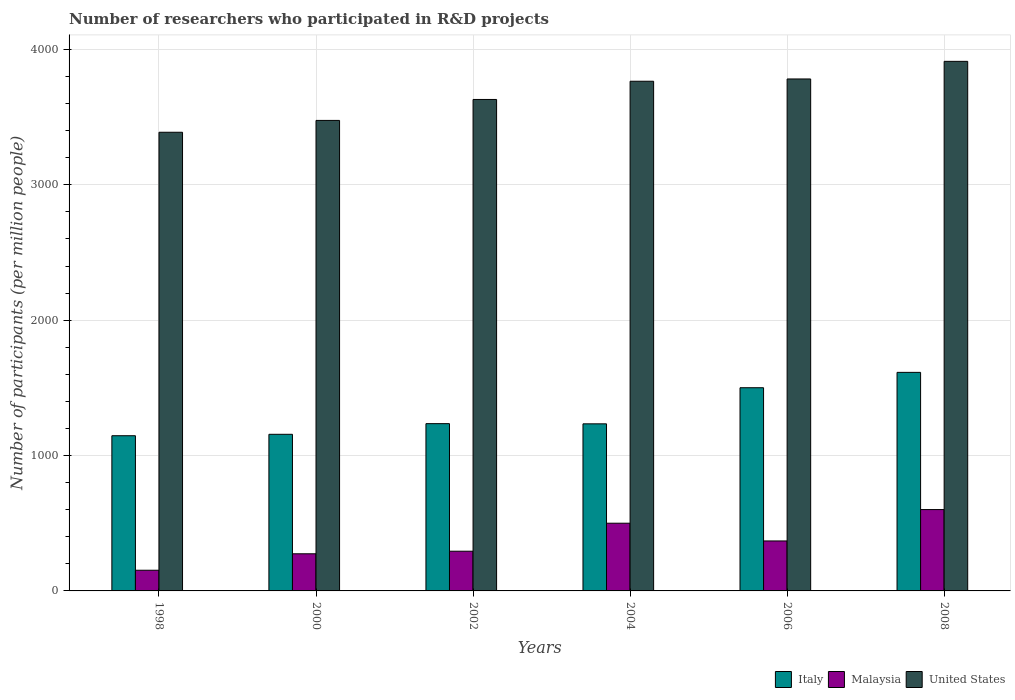Are the number of bars per tick equal to the number of legend labels?
Provide a succinct answer. Yes. What is the number of researchers who participated in R&D projects in Italy in 2002?
Ensure brevity in your answer.  1235.65. Across all years, what is the maximum number of researchers who participated in R&D projects in Italy?
Provide a short and direct response. 1614.42. Across all years, what is the minimum number of researchers who participated in R&D projects in Italy?
Give a very brief answer. 1146.34. What is the total number of researchers who participated in R&D projects in United States in the graph?
Make the answer very short. 2.20e+04. What is the difference between the number of researchers who participated in R&D projects in Malaysia in 2004 and that in 2006?
Your answer should be very brief. 131.01. What is the difference between the number of researchers who participated in R&D projects in Malaysia in 2000 and the number of researchers who participated in R&D projects in Italy in 2008?
Ensure brevity in your answer.  -1340.18. What is the average number of researchers who participated in R&D projects in Italy per year?
Keep it short and to the point. 1314.72. In the year 2000, what is the difference between the number of researchers who participated in R&D projects in Malaysia and number of researchers who participated in R&D projects in Italy?
Provide a short and direct response. -882.6. What is the ratio of the number of researchers who participated in R&D projects in United States in 2004 to that in 2008?
Keep it short and to the point. 0.96. What is the difference between the highest and the second highest number of researchers who participated in R&D projects in Malaysia?
Provide a succinct answer. 100.82. What is the difference between the highest and the lowest number of researchers who participated in R&D projects in United States?
Give a very brief answer. 523.75. Is the sum of the number of researchers who participated in R&D projects in United States in 1998 and 2000 greater than the maximum number of researchers who participated in R&D projects in Italy across all years?
Keep it short and to the point. Yes. What does the 1st bar from the left in 2008 represents?
Give a very brief answer. Italy. What does the 3rd bar from the right in 2008 represents?
Ensure brevity in your answer.  Italy. Is it the case that in every year, the sum of the number of researchers who participated in R&D projects in Malaysia and number of researchers who participated in R&D projects in United States is greater than the number of researchers who participated in R&D projects in Italy?
Provide a short and direct response. Yes. How many bars are there?
Keep it short and to the point. 18. Are all the bars in the graph horizontal?
Your answer should be compact. No. What is the difference between two consecutive major ticks on the Y-axis?
Make the answer very short. 1000. Does the graph contain any zero values?
Provide a short and direct response. No. Where does the legend appear in the graph?
Ensure brevity in your answer.  Bottom right. What is the title of the graph?
Provide a succinct answer. Number of researchers who participated in R&D projects. What is the label or title of the Y-axis?
Provide a succinct answer. Number of participants (per million people). What is the Number of participants (per million people) in Italy in 1998?
Provide a short and direct response. 1146.34. What is the Number of participants (per million people) of Malaysia in 1998?
Provide a succinct answer. 152.79. What is the Number of participants (per million people) in United States in 1998?
Give a very brief answer. 3388.01. What is the Number of participants (per million people) in Italy in 2000?
Ensure brevity in your answer.  1156.84. What is the Number of participants (per million people) in Malaysia in 2000?
Provide a succinct answer. 274.24. What is the Number of participants (per million people) of United States in 2000?
Your answer should be compact. 3475.52. What is the Number of participants (per million people) of Italy in 2002?
Your answer should be compact. 1235.65. What is the Number of participants (per million people) of Malaysia in 2002?
Your response must be concise. 293.3. What is the Number of participants (per million people) in United States in 2002?
Offer a very short reply. 3630.32. What is the Number of participants (per million people) in Italy in 2004?
Provide a succinct answer. 1234.18. What is the Number of participants (per million people) in Malaysia in 2004?
Give a very brief answer. 500.14. What is the Number of participants (per million people) in United States in 2004?
Ensure brevity in your answer.  3764.84. What is the Number of participants (per million people) of Italy in 2006?
Provide a succinct answer. 1500.88. What is the Number of participants (per million people) in Malaysia in 2006?
Your answer should be very brief. 369.12. What is the Number of participants (per million people) of United States in 2006?
Your answer should be compact. 3781.64. What is the Number of participants (per million people) of Italy in 2008?
Give a very brief answer. 1614.42. What is the Number of participants (per million people) in Malaysia in 2008?
Ensure brevity in your answer.  600.96. What is the Number of participants (per million people) in United States in 2008?
Your answer should be very brief. 3911.75. Across all years, what is the maximum Number of participants (per million people) of Italy?
Your response must be concise. 1614.42. Across all years, what is the maximum Number of participants (per million people) of Malaysia?
Keep it short and to the point. 600.96. Across all years, what is the maximum Number of participants (per million people) of United States?
Provide a succinct answer. 3911.75. Across all years, what is the minimum Number of participants (per million people) of Italy?
Your response must be concise. 1146.34. Across all years, what is the minimum Number of participants (per million people) in Malaysia?
Offer a terse response. 152.79. Across all years, what is the minimum Number of participants (per million people) of United States?
Your response must be concise. 3388.01. What is the total Number of participants (per million people) of Italy in the graph?
Provide a succinct answer. 7888.31. What is the total Number of participants (per million people) in Malaysia in the graph?
Your answer should be compact. 2190.55. What is the total Number of participants (per million people) in United States in the graph?
Your answer should be compact. 2.20e+04. What is the difference between the Number of participants (per million people) in Italy in 1998 and that in 2000?
Provide a short and direct response. -10.5. What is the difference between the Number of participants (per million people) in Malaysia in 1998 and that in 2000?
Your response must be concise. -121.46. What is the difference between the Number of participants (per million people) in United States in 1998 and that in 2000?
Provide a short and direct response. -87.51. What is the difference between the Number of participants (per million people) in Italy in 1998 and that in 2002?
Your response must be concise. -89.3. What is the difference between the Number of participants (per million people) of Malaysia in 1998 and that in 2002?
Provide a short and direct response. -140.51. What is the difference between the Number of participants (per million people) in United States in 1998 and that in 2002?
Provide a short and direct response. -242.31. What is the difference between the Number of participants (per million people) of Italy in 1998 and that in 2004?
Your answer should be very brief. -87.83. What is the difference between the Number of participants (per million people) of Malaysia in 1998 and that in 2004?
Keep it short and to the point. -347.35. What is the difference between the Number of participants (per million people) in United States in 1998 and that in 2004?
Provide a short and direct response. -376.83. What is the difference between the Number of participants (per million people) of Italy in 1998 and that in 2006?
Provide a short and direct response. -354.54. What is the difference between the Number of participants (per million people) of Malaysia in 1998 and that in 2006?
Offer a very short reply. -216.34. What is the difference between the Number of participants (per million people) in United States in 1998 and that in 2006?
Your answer should be compact. -393.63. What is the difference between the Number of participants (per million people) of Italy in 1998 and that in 2008?
Give a very brief answer. -468.08. What is the difference between the Number of participants (per million people) of Malaysia in 1998 and that in 2008?
Make the answer very short. -448.17. What is the difference between the Number of participants (per million people) in United States in 1998 and that in 2008?
Keep it short and to the point. -523.75. What is the difference between the Number of participants (per million people) of Italy in 2000 and that in 2002?
Your answer should be compact. -78.81. What is the difference between the Number of participants (per million people) in Malaysia in 2000 and that in 2002?
Your answer should be very brief. -19.05. What is the difference between the Number of participants (per million people) of United States in 2000 and that in 2002?
Provide a short and direct response. -154.81. What is the difference between the Number of participants (per million people) in Italy in 2000 and that in 2004?
Your answer should be very brief. -77.34. What is the difference between the Number of participants (per million people) in Malaysia in 2000 and that in 2004?
Keep it short and to the point. -225.89. What is the difference between the Number of participants (per million people) in United States in 2000 and that in 2004?
Your answer should be compact. -289.32. What is the difference between the Number of participants (per million people) in Italy in 2000 and that in 2006?
Offer a very short reply. -344.04. What is the difference between the Number of participants (per million people) in Malaysia in 2000 and that in 2006?
Your response must be concise. -94.88. What is the difference between the Number of participants (per million people) in United States in 2000 and that in 2006?
Offer a terse response. -306.12. What is the difference between the Number of participants (per million people) of Italy in 2000 and that in 2008?
Offer a terse response. -457.58. What is the difference between the Number of participants (per million people) of Malaysia in 2000 and that in 2008?
Your answer should be very brief. -326.71. What is the difference between the Number of participants (per million people) in United States in 2000 and that in 2008?
Give a very brief answer. -436.24. What is the difference between the Number of participants (per million people) in Italy in 2002 and that in 2004?
Your response must be concise. 1.47. What is the difference between the Number of participants (per million people) in Malaysia in 2002 and that in 2004?
Make the answer very short. -206.84. What is the difference between the Number of participants (per million people) in United States in 2002 and that in 2004?
Provide a succinct answer. -134.52. What is the difference between the Number of participants (per million people) in Italy in 2002 and that in 2006?
Provide a short and direct response. -265.23. What is the difference between the Number of participants (per million people) in Malaysia in 2002 and that in 2006?
Ensure brevity in your answer.  -75.83. What is the difference between the Number of participants (per million people) of United States in 2002 and that in 2006?
Keep it short and to the point. -151.31. What is the difference between the Number of participants (per million people) in Italy in 2002 and that in 2008?
Ensure brevity in your answer.  -378.78. What is the difference between the Number of participants (per million people) of Malaysia in 2002 and that in 2008?
Keep it short and to the point. -307.66. What is the difference between the Number of participants (per million people) of United States in 2002 and that in 2008?
Your answer should be compact. -281.43. What is the difference between the Number of participants (per million people) of Italy in 2004 and that in 2006?
Your answer should be compact. -266.7. What is the difference between the Number of participants (per million people) in Malaysia in 2004 and that in 2006?
Provide a short and direct response. 131.01. What is the difference between the Number of participants (per million people) in United States in 2004 and that in 2006?
Provide a succinct answer. -16.8. What is the difference between the Number of participants (per million people) in Italy in 2004 and that in 2008?
Your response must be concise. -380.25. What is the difference between the Number of participants (per million people) in Malaysia in 2004 and that in 2008?
Your answer should be very brief. -100.82. What is the difference between the Number of participants (per million people) of United States in 2004 and that in 2008?
Provide a succinct answer. -146.92. What is the difference between the Number of participants (per million people) of Italy in 2006 and that in 2008?
Keep it short and to the point. -113.54. What is the difference between the Number of participants (per million people) in Malaysia in 2006 and that in 2008?
Offer a terse response. -231.84. What is the difference between the Number of participants (per million people) in United States in 2006 and that in 2008?
Ensure brevity in your answer.  -130.12. What is the difference between the Number of participants (per million people) of Italy in 1998 and the Number of participants (per million people) of Malaysia in 2000?
Provide a short and direct response. 872.1. What is the difference between the Number of participants (per million people) of Italy in 1998 and the Number of participants (per million people) of United States in 2000?
Provide a succinct answer. -2329.17. What is the difference between the Number of participants (per million people) of Malaysia in 1998 and the Number of participants (per million people) of United States in 2000?
Keep it short and to the point. -3322.73. What is the difference between the Number of participants (per million people) of Italy in 1998 and the Number of participants (per million people) of Malaysia in 2002?
Give a very brief answer. 853.05. What is the difference between the Number of participants (per million people) of Italy in 1998 and the Number of participants (per million people) of United States in 2002?
Ensure brevity in your answer.  -2483.98. What is the difference between the Number of participants (per million people) in Malaysia in 1998 and the Number of participants (per million people) in United States in 2002?
Offer a very short reply. -3477.54. What is the difference between the Number of participants (per million people) of Italy in 1998 and the Number of participants (per million people) of Malaysia in 2004?
Offer a very short reply. 646.2. What is the difference between the Number of participants (per million people) of Italy in 1998 and the Number of participants (per million people) of United States in 2004?
Your answer should be very brief. -2618.5. What is the difference between the Number of participants (per million people) of Malaysia in 1998 and the Number of participants (per million people) of United States in 2004?
Offer a terse response. -3612.05. What is the difference between the Number of participants (per million people) in Italy in 1998 and the Number of participants (per million people) in Malaysia in 2006?
Provide a short and direct response. 777.22. What is the difference between the Number of participants (per million people) in Italy in 1998 and the Number of participants (per million people) in United States in 2006?
Your response must be concise. -2635.29. What is the difference between the Number of participants (per million people) in Malaysia in 1998 and the Number of participants (per million people) in United States in 2006?
Your response must be concise. -3628.85. What is the difference between the Number of participants (per million people) of Italy in 1998 and the Number of participants (per million people) of Malaysia in 2008?
Your response must be concise. 545.38. What is the difference between the Number of participants (per million people) in Italy in 1998 and the Number of participants (per million people) in United States in 2008?
Offer a terse response. -2765.41. What is the difference between the Number of participants (per million people) of Malaysia in 1998 and the Number of participants (per million people) of United States in 2008?
Make the answer very short. -3758.97. What is the difference between the Number of participants (per million people) of Italy in 2000 and the Number of participants (per million people) of Malaysia in 2002?
Ensure brevity in your answer.  863.54. What is the difference between the Number of participants (per million people) in Italy in 2000 and the Number of participants (per million people) in United States in 2002?
Ensure brevity in your answer.  -2473.48. What is the difference between the Number of participants (per million people) of Malaysia in 2000 and the Number of participants (per million people) of United States in 2002?
Provide a succinct answer. -3356.08. What is the difference between the Number of participants (per million people) of Italy in 2000 and the Number of participants (per million people) of Malaysia in 2004?
Keep it short and to the point. 656.7. What is the difference between the Number of participants (per million people) of Italy in 2000 and the Number of participants (per million people) of United States in 2004?
Make the answer very short. -2608. What is the difference between the Number of participants (per million people) in Malaysia in 2000 and the Number of participants (per million people) in United States in 2004?
Offer a very short reply. -3490.6. What is the difference between the Number of participants (per million people) in Italy in 2000 and the Number of participants (per million people) in Malaysia in 2006?
Keep it short and to the point. 787.72. What is the difference between the Number of participants (per million people) of Italy in 2000 and the Number of participants (per million people) of United States in 2006?
Provide a short and direct response. -2624.8. What is the difference between the Number of participants (per million people) of Malaysia in 2000 and the Number of participants (per million people) of United States in 2006?
Your response must be concise. -3507.39. What is the difference between the Number of participants (per million people) in Italy in 2000 and the Number of participants (per million people) in Malaysia in 2008?
Offer a very short reply. 555.88. What is the difference between the Number of participants (per million people) of Italy in 2000 and the Number of participants (per million people) of United States in 2008?
Provide a short and direct response. -2754.91. What is the difference between the Number of participants (per million people) of Malaysia in 2000 and the Number of participants (per million people) of United States in 2008?
Keep it short and to the point. -3637.51. What is the difference between the Number of participants (per million people) of Italy in 2002 and the Number of participants (per million people) of Malaysia in 2004?
Provide a succinct answer. 735.51. What is the difference between the Number of participants (per million people) of Italy in 2002 and the Number of participants (per million people) of United States in 2004?
Your answer should be compact. -2529.19. What is the difference between the Number of participants (per million people) in Malaysia in 2002 and the Number of participants (per million people) in United States in 2004?
Provide a short and direct response. -3471.54. What is the difference between the Number of participants (per million people) of Italy in 2002 and the Number of participants (per million people) of Malaysia in 2006?
Provide a succinct answer. 866.52. What is the difference between the Number of participants (per million people) in Italy in 2002 and the Number of participants (per million people) in United States in 2006?
Your response must be concise. -2545.99. What is the difference between the Number of participants (per million people) in Malaysia in 2002 and the Number of participants (per million people) in United States in 2006?
Keep it short and to the point. -3488.34. What is the difference between the Number of participants (per million people) of Italy in 2002 and the Number of participants (per million people) of Malaysia in 2008?
Ensure brevity in your answer.  634.69. What is the difference between the Number of participants (per million people) in Italy in 2002 and the Number of participants (per million people) in United States in 2008?
Make the answer very short. -2676.11. What is the difference between the Number of participants (per million people) of Malaysia in 2002 and the Number of participants (per million people) of United States in 2008?
Keep it short and to the point. -3618.46. What is the difference between the Number of participants (per million people) of Italy in 2004 and the Number of participants (per million people) of Malaysia in 2006?
Your answer should be very brief. 865.05. What is the difference between the Number of participants (per million people) in Italy in 2004 and the Number of participants (per million people) in United States in 2006?
Offer a very short reply. -2547.46. What is the difference between the Number of participants (per million people) of Malaysia in 2004 and the Number of participants (per million people) of United States in 2006?
Provide a short and direct response. -3281.5. What is the difference between the Number of participants (per million people) in Italy in 2004 and the Number of participants (per million people) in Malaysia in 2008?
Give a very brief answer. 633.22. What is the difference between the Number of participants (per million people) of Italy in 2004 and the Number of participants (per million people) of United States in 2008?
Provide a succinct answer. -2677.58. What is the difference between the Number of participants (per million people) in Malaysia in 2004 and the Number of participants (per million people) in United States in 2008?
Your answer should be very brief. -3411.62. What is the difference between the Number of participants (per million people) in Italy in 2006 and the Number of participants (per million people) in Malaysia in 2008?
Make the answer very short. 899.92. What is the difference between the Number of participants (per million people) of Italy in 2006 and the Number of participants (per million people) of United States in 2008?
Ensure brevity in your answer.  -2410.87. What is the difference between the Number of participants (per million people) in Malaysia in 2006 and the Number of participants (per million people) in United States in 2008?
Offer a very short reply. -3542.63. What is the average Number of participants (per million people) of Italy per year?
Offer a terse response. 1314.72. What is the average Number of participants (per million people) in Malaysia per year?
Your answer should be compact. 365.09. What is the average Number of participants (per million people) in United States per year?
Ensure brevity in your answer.  3658.68. In the year 1998, what is the difference between the Number of participants (per million people) of Italy and Number of participants (per million people) of Malaysia?
Give a very brief answer. 993.56. In the year 1998, what is the difference between the Number of participants (per million people) of Italy and Number of participants (per million people) of United States?
Your response must be concise. -2241.67. In the year 1998, what is the difference between the Number of participants (per million people) of Malaysia and Number of participants (per million people) of United States?
Make the answer very short. -3235.22. In the year 2000, what is the difference between the Number of participants (per million people) in Italy and Number of participants (per million people) in Malaysia?
Ensure brevity in your answer.  882.6. In the year 2000, what is the difference between the Number of participants (per million people) of Italy and Number of participants (per million people) of United States?
Make the answer very short. -2318.68. In the year 2000, what is the difference between the Number of participants (per million people) of Malaysia and Number of participants (per million people) of United States?
Your answer should be very brief. -3201.27. In the year 2002, what is the difference between the Number of participants (per million people) of Italy and Number of participants (per million people) of Malaysia?
Provide a short and direct response. 942.35. In the year 2002, what is the difference between the Number of participants (per million people) in Italy and Number of participants (per million people) in United States?
Offer a terse response. -2394.68. In the year 2002, what is the difference between the Number of participants (per million people) in Malaysia and Number of participants (per million people) in United States?
Ensure brevity in your answer.  -3337.03. In the year 2004, what is the difference between the Number of participants (per million people) of Italy and Number of participants (per million people) of Malaysia?
Provide a succinct answer. 734.04. In the year 2004, what is the difference between the Number of participants (per million people) in Italy and Number of participants (per million people) in United States?
Your response must be concise. -2530.66. In the year 2004, what is the difference between the Number of participants (per million people) of Malaysia and Number of participants (per million people) of United States?
Offer a very short reply. -3264.7. In the year 2006, what is the difference between the Number of participants (per million people) in Italy and Number of participants (per million people) in Malaysia?
Your response must be concise. 1131.76. In the year 2006, what is the difference between the Number of participants (per million people) of Italy and Number of participants (per million people) of United States?
Give a very brief answer. -2280.76. In the year 2006, what is the difference between the Number of participants (per million people) of Malaysia and Number of participants (per million people) of United States?
Offer a terse response. -3412.51. In the year 2008, what is the difference between the Number of participants (per million people) of Italy and Number of participants (per million people) of Malaysia?
Provide a succinct answer. 1013.46. In the year 2008, what is the difference between the Number of participants (per million people) of Italy and Number of participants (per million people) of United States?
Ensure brevity in your answer.  -2297.33. In the year 2008, what is the difference between the Number of participants (per million people) of Malaysia and Number of participants (per million people) of United States?
Provide a short and direct response. -3310.8. What is the ratio of the Number of participants (per million people) in Italy in 1998 to that in 2000?
Offer a very short reply. 0.99. What is the ratio of the Number of participants (per million people) in Malaysia in 1998 to that in 2000?
Offer a very short reply. 0.56. What is the ratio of the Number of participants (per million people) in United States in 1998 to that in 2000?
Ensure brevity in your answer.  0.97. What is the ratio of the Number of participants (per million people) in Italy in 1998 to that in 2002?
Give a very brief answer. 0.93. What is the ratio of the Number of participants (per million people) in Malaysia in 1998 to that in 2002?
Provide a short and direct response. 0.52. What is the ratio of the Number of participants (per million people) in United States in 1998 to that in 2002?
Give a very brief answer. 0.93. What is the ratio of the Number of participants (per million people) of Italy in 1998 to that in 2004?
Provide a succinct answer. 0.93. What is the ratio of the Number of participants (per million people) of Malaysia in 1998 to that in 2004?
Offer a terse response. 0.31. What is the ratio of the Number of participants (per million people) in United States in 1998 to that in 2004?
Provide a succinct answer. 0.9. What is the ratio of the Number of participants (per million people) in Italy in 1998 to that in 2006?
Make the answer very short. 0.76. What is the ratio of the Number of participants (per million people) in Malaysia in 1998 to that in 2006?
Give a very brief answer. 0.41. What is the ratio of the Number of participants (per million people) in United States in 1998 to that in 2006?
Offer a terse response. 0.9. What is the ratio of the Number of participants (per million people) in Italy in 1998 to that in 2008?
Give a very brief answer. 0.71. What is the ratio of the Number of participants (per million people) in Malaysia in 1998 to that in 2008?
Provide a succinct answer. 0.25. What is the ratio of the Number of participants (per million people) of United States in 1998 to that in 2008?
Offer a very short reply. 0.87. What is the ratio of the Number of participants (per million people) of Italy in 2000 to that in 2002?
Your response must be concise. 0.94. What is the ratio of the Number of participants (per million people) of Malaysia in 2000 to that in 2002?
Provide a short and direct response. 0.94. What is the ratio of the Number of participants (per million people) of United States in 2000 to that in 2002?
Your answer should be compact. 0.96. What is the ratio of the Number of participants (per million people) in Italy in 2000 to that in 2004?
Offer a terse response. 0.94. What is the ratio of the Number of participants (per million people) of Malaysia in 2000 to that in 2004?
Provide a short and direct response. 0.55. What is the ratio of the Number of participants (per million people) in United States in 2000 to that in 2004?
Your answer should be compact. 0.92. What is the ratio of the Number of participants (per million people) of Italy in 2000 to that in 2006?
Make the answer very short. 0.77. What is the ratio of the Number of participants (per million people) of Malaysia in 2000 to that in 2006?
Your response must be concise. 0.74. What is the ratio of the Number of participants (per million people) of United States in 2000 to that in 2006?
Make the answer very short. 0.92. What is the ratio of the Number of participants (per million people) in Italy in 2000 to that in 2008?
Make the answer very short. 0.72. What is the ratio of the Number of participants (per million people) in Malaysia in 2000 to that in 2008?
Make the answer very short. 0.46. What is the ratio of the Number of participants (per million people) in United States in 2000 to that in 2008?
Make the answer very short. 0.89. What is the ratio of the Number of participants (per million people) of Malaysia in 2002 to that in 2004?
Offer a very short reply. 0.59. What is the ratio of the Number of participants (per million people) of Italy in 2002 to that in 2006?
Offer a terse response. 0.82. What is the ratio of the Number of participants (per million people) in Malaysia in 2002 to that in 2006?
Offer a terse response. 0.79. What is the ratio of the Number of participants (per million people) in Italy in 2002 to that in 2008?
Your response must be concise. 0.77. What is the ratio of the Number of participants (per million people) in Malaysia in 2002 to that in 2008?
Your answer should be very brief. 0.49. What is the ratio of the Number of participants (per million people) of United States in 2002 to that in 2008?
Give a very brief answer. 0.93. What is the ratio of the Number of participants (per million people) in Italy in 2004 to that in 2006?
Your answer should be compact. 0.82. What is the ratio of the Number of participants (per million people) in Malaysia in 2004 to that in 2006?
Offer a very short reply. 1.35. What is the ratio of the Number of participants (per million people) of United States in 2004 to that in 2006?
Keep it short and to the point. 1. What is the ratio of the Number of participants (per million people) in Italy in 2004 to that in 2008?
Provide a succinct answer. 0.76. What is the ratio of the Number of participants (per million people) in Malaysia in 2004 to that in 2008?
Offer a terse response. 0.83. What is the ratio of the Number of participants (per million people) of United States in 2004 to that in 2008?
Your answer should be very brief. 0.96. What is the ratio of the Number of participants (per million people) of Italy in 2006 to that in 2008?
Provide a short and direct response. 0.93. What is the ratio of the Number of participants (per million people) of Malaysia in 2006 to that in 2008?
Offer a very short reply. 0.61. What is the ratio of the Number of participants (per million people) of United States in 2006 to that in 2008?
Provide a short and direct response. 0.97. What is the difference between the highest and the second highest Number of participants (per million people) of Italy?
Your answer should be compact. 113.54. What is the difference between the highest and the second highest Number of participants (per million people) of Malaysia?
Offer a very short reply. 100.82. What is the difference between the highest and the second highest Number of participants (per million people) of United States?
Your response must be concise. 130.12. What is the difference between the highest and the lowest Number of participants (per million people) of Italy?
Provide a succinct answer. 468.08. What is the difference between the highest and the lowest Number of participants (per million people) in Malaysia?
Give a very brief answer. 448.17. What is the difference between the highest and the lowest Number of participants (per million people) in United States?
Offer a terse response. 523.75. 